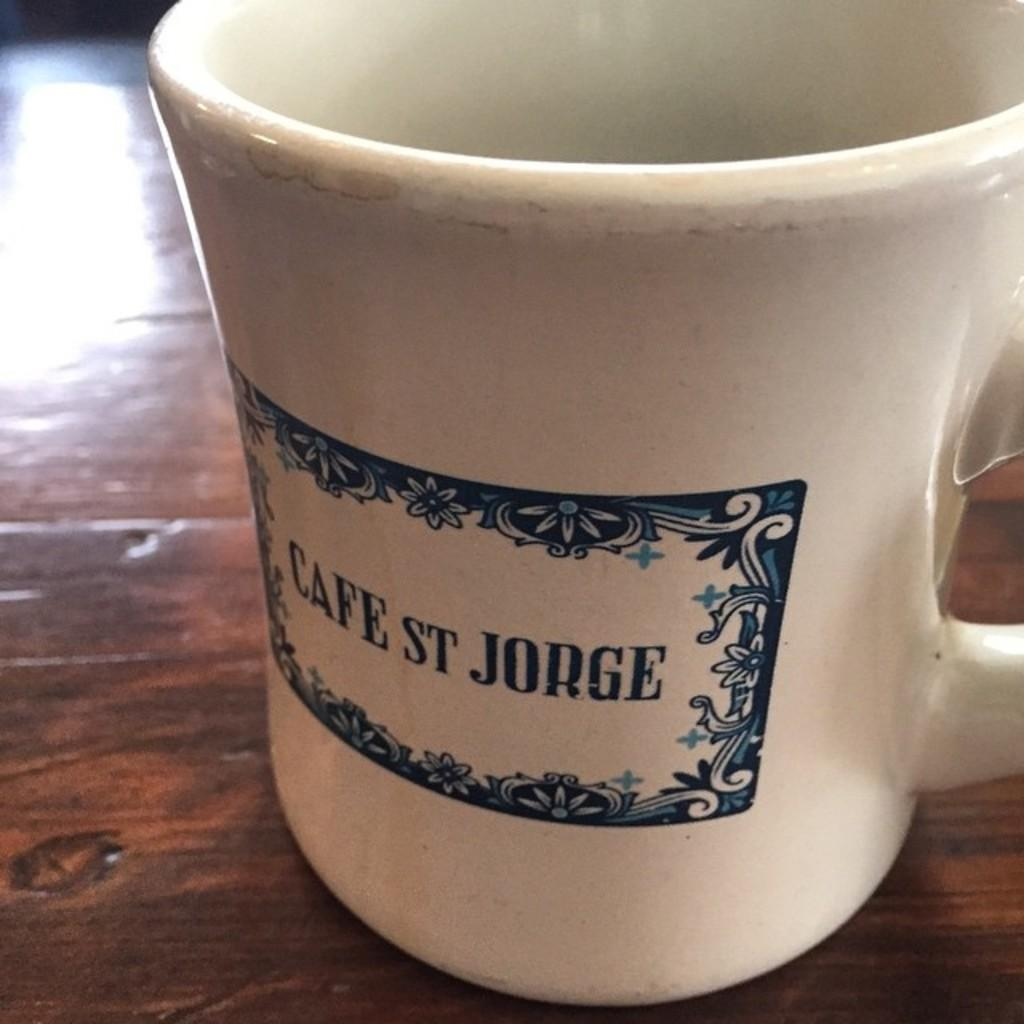<image>
Relay a brief, clear account of the picture shown. The mug on the table is from Cafe ST Jorge. 